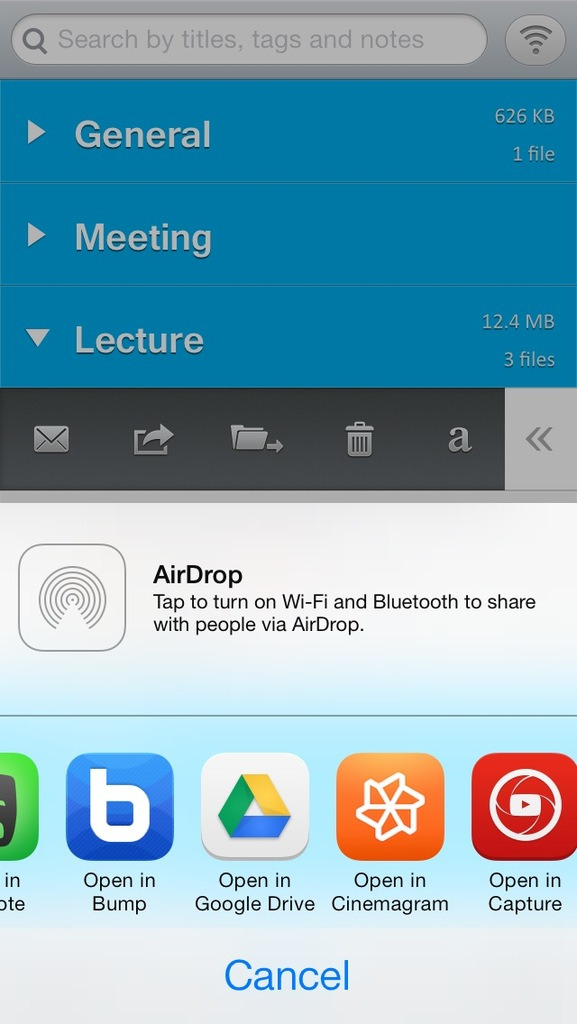Provide a one-sentence caption for the provided image. The image shows a smartphone's file management screen, highlighting folders named 'General', 'Meeting', and 'Lecture', with options for sharing files through AirDrop alongside other apps like Google Drive and Bump. 